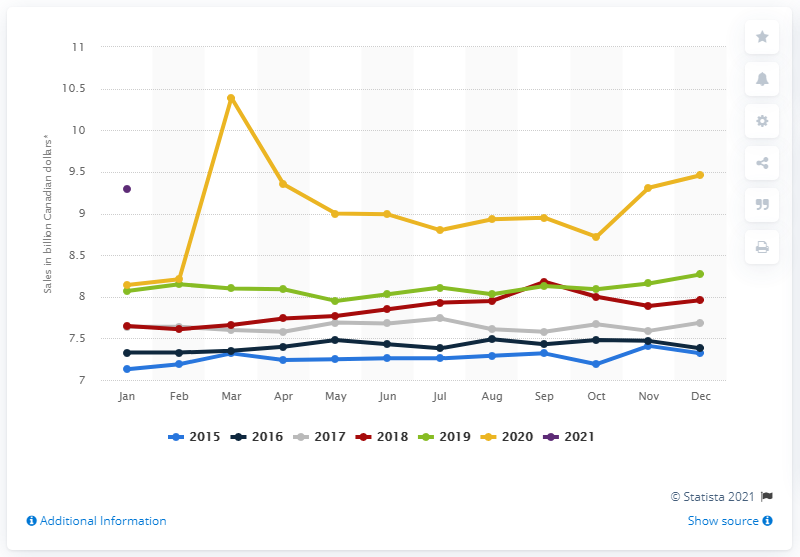What might account for the significant drop in sales following the peak in March 2020? The significant drop in sales after March 2020's peak could be due to a few factors, such as the stabilization of purchasing patterns after the initial panic buying, as well as consumers depleting their stockpiled goods. Another factor could be the economic uncertainty leading to more conservative spending. 